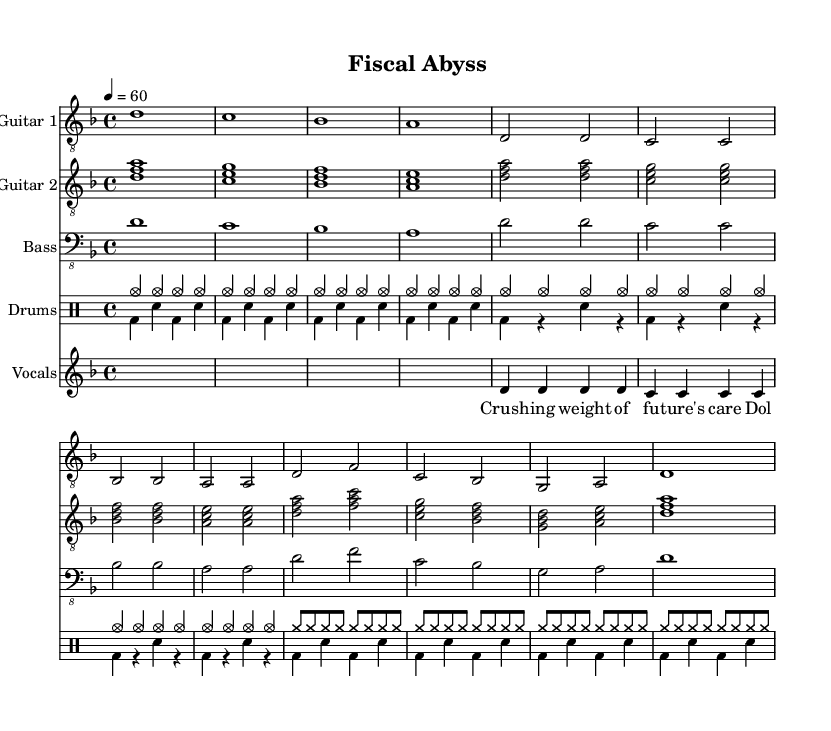What is the key signature of this music? The key signature is D minor, which is indicated by one flat (B flat) in the music staff.
Answer: D minor What is the time signature of this music? The time signature (shown at the beginning) is 4/4, meaning there are four beats in each measure.
Answer: 4/4 What is the tempo marking of this music? The tempo is set at 60 beats per minute, indicated by the marking "4 = 60".
Answer: 60 How many measures are in the Main Riff? Counting the measures within the labeled "Main Riff" section, there are four measures represented.
Answer: 4 What is the instrumental structure of this piece? The piece features two guitars, bass, and drums, alongside vocal lyrics, forming a typical Metal band setup.
Answer: Two guitars, bass, drums, vocals What is the main thematic focus of the lyrics? The lyrics express the burdens related to future healthcare costs and financial implications of long-term care.
Answer: Healthcare costs What type of musical elements are used in the Chorus section? The Chorus includes a combination of power chords played by the guitars and a strong rhythm section with drums, typical in Metal music.
Answer: Power chords and strong rhythm 